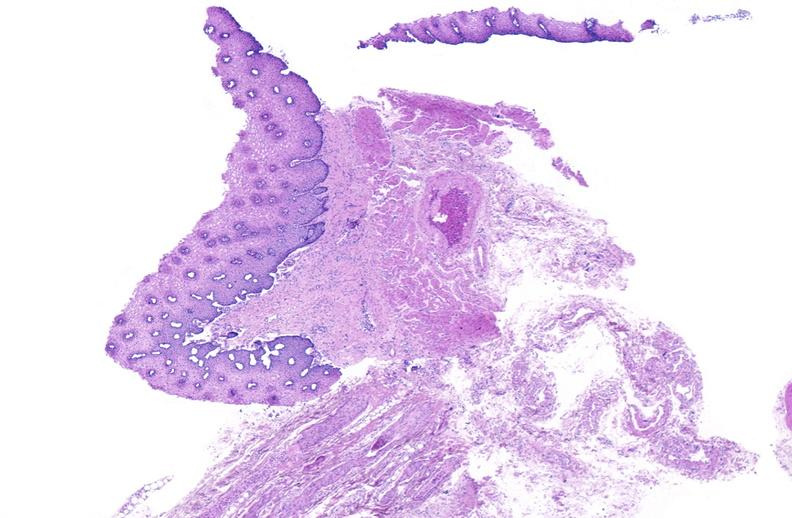s gastrointestinal present?
Answer the question using a single word or phrase. Yes 